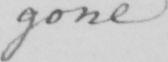Please provide the text content of this handwritten line. gone 